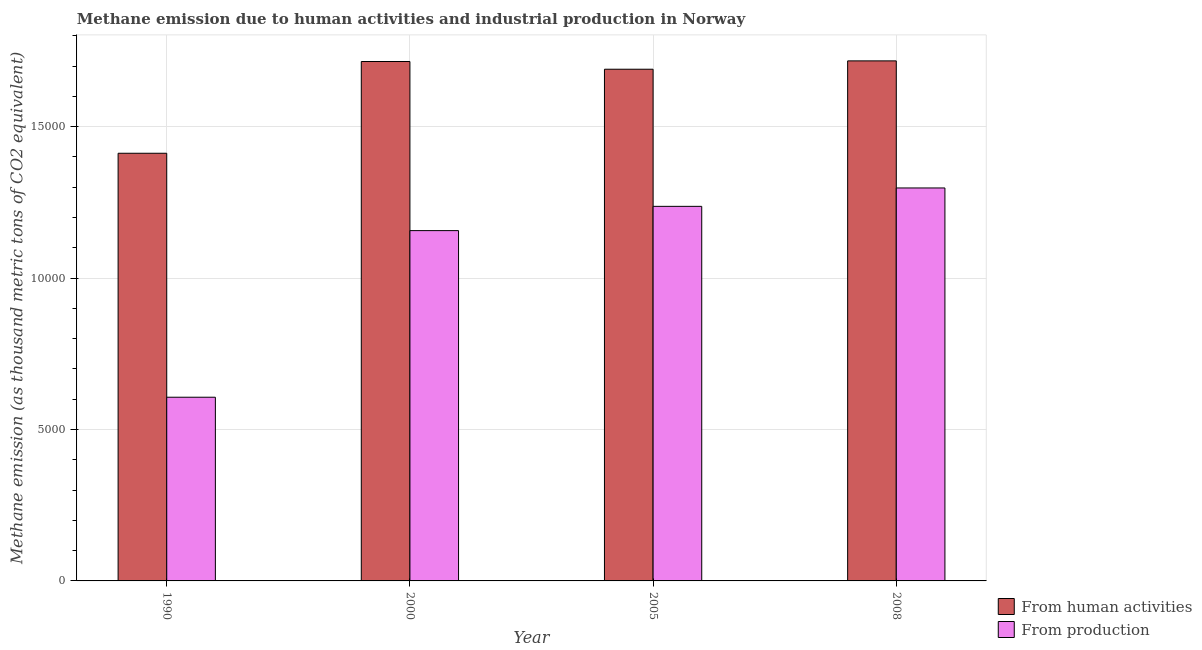Are the number of bars on each tick of the X-axis equal?
Provide a succinct answer. Yes. How many bars are there on the 3rd tick from the right?
Provide a succinct answer. 2. What is the label of the 1st group of bars from the left?
Keep it short and to the point. 1990. What is the amount of emissions from human activities in 2000?
Offer a terse response. 1.72e+04. Across all years, what is the maximum amount of emissions from human activities?
Offer a terse response. 1.72e+04. Across all years, what is the minimum amount of emissions generated from industries?
Your answer should be very brief. 6065.9. In which year was the amount of emissions generated from industries minimum?
Keep it short and to the point. 1990. What is the total amount of emissions generated from industries in the graph?
Your answer should be very brief. 4.30e+04. What is the difference between the amount of emissions generated from industries in 2000 and that in 2005?
Provide a succinct answer. -801. What is the difference between the amount of emissions generated from industries in 1990 and the amount of emissions from human activities in 2005?
Give a very brief answer. -6302.9. What is the average amount of emissions from human activities per year?
Your answer should be compact. 1.63e+04. What is the ratio of the amount of emissions from human activities in 2000 to that in 2005?
Your response must be concise. 1.02. Is the difference between the amount of emissions generated from industries in 2005 and 2008 greater than the difference between the amount of emissions from human activities in 2005 and 2008?
Offer a terse response. No. What is the difference between the highest and the second highest amount of emissions from human activities?
Offer a terse response. 21. What is the difference between the highest and the lowest amount of emissions generated from industries?
Offer a terse response. 6910.1. Is the sum of the amount of emissions generated from industries in 2005 and 2008 greater than the maximum amount of emissions from human activities across all years?
Give a very brief answer. Yes. What does the 1st bar from the left in 2005 represents?
Your response must be concise. From human activities. What does the 1st bar from the right in 2008 represents?
Your answer should be very brief. From production. How many bars are there?
Make the answer very short. 8. Are all the bars in the graph horizontal?
Make the answer very short. No. How many years are there in the graph?
Keep it short and to the point. 4. What is the difference between two consecutive major ticks on the Y-axis?
Provide a short and direct response. 5000. Are the values on the major ticks of Y-axis written in scientific E-notation?
Keep it short and to the point. No. Does the graph contain grids?
Offer a terse response. Yes. What is the title of the graph?
Your answer should be very brief. Methane emission due to human activities and industrial production in Norway. Does "Fixed telephone" appear as one of the legend labels in the graph?
Your answer should be very brief. No. What is the label or title of the Y-axis?
Ensure brevity in your answer.  Methane emission (as thousand metric tons of CO2 equivalent). What is the Methane emission (as thousand metric tons of CO2 equivalent) of From human activities in 1990?
Your answer should be very brief. 1.41e+04. What is the Methane emission (as thousand metric tons of CO2 equivalent) in From production in 1990?
Your response must be concise. 6065.9. What is the Methane emission (as thousand metric tons of CO2 equivalent) of From human activities in 2000?
Offer a terse response. 1.72e+04. What is the Methane emission (as thousand metric tons of CO2 equivalent) in From production in 2000?
Provide a short and direct response. 1.16e+04. What is the Methane emission (as thousand metric tons of CO2 equivalent) of From human activities in 2005?
Keep it short and to the point. 1.69e+04. What is the Methane emission (as thousand metric tons of CO2 equivalent) of From production in 2005?
Give a very brief answer. 1.24e+04. What is the Methane emission (as thousand metric tons of CO2 equivalent) of From human activities in 2008?
Ensure brevity in your answer.  1.72e+04. What is the Methane emission (as thousand metric tons of CO2 equivalent) of From production in 2008?
Make the answer very short. 1.30e+04. Across all years, what is the maximum Methane emission (as thousand metric tons of CO2 equivalent) of From human activities?
Ensure brevity in your answer.  1.72e+04. Across all years, what is the maximum Methane emission (as thousand metric tons of CO2 equivalent) of From production?
Your answer should be compact. 1.30e+04. Across all years, what is the minimum Methane emission (as thousand metric tons of CO2 equivalent) in From human activities?
Offer a very short reply. 1.41e+04. Across all years, what is the minimum Methane emission (as thousand metric tons of CO2 equivalent) of From production?
Offer a very short reply. 6065.9. What is the total Methane emission (as thousand metric tons of CO2 equivalent) of From human activities in the graph?
Give a very brief answer. 6.53e+04. What is the total Methane emission (as thousand metric tons of CO2 equivalent) in From production in the graph?
Your answer should be compact. 4.30e+04. What is the difference between the Methane emission (as thousand metric tons of CO2 equivalent) in From human activities in 1990 and that in 2000?
Offer a terse response. -3029.8. What is the difference between the Methane emission (as thousand metric tons of CO2 equivalent) in From production in 1990 and that in 2000?
Give a very brief answer. -5501.9. What is the difference between the Methane emission (as thousand metric tons of CO2 equivalent) of From human activities in 1990 and that in 2005?
Your answer should be very brief. -2775. What is the difference between the Methane emission (as thousand metric tons of CO2 equivalent) in From production in 1990 and that in 2005?
Offer a terse response. -6302.9. What is the difference between the Methane emission (as thousand metric tons of CO2 equivalent) of From human activities in 1990 and that in 2008?
Give a very brief answer. -3050.8. What is the difference between the Methane emission (as thousand metric tons of CO2 equivalent) in From production in 1990 and that in 2008?
Your response must be concise. -6910.1. What is the difference between the Methane emission (as thousand metric tons of CO2 equivalent) in From human activities in 2000 and that in 2005?
Keep it short and to the point. 254.8. What is the difference between the Methane emission (as thousand metric tons of CO2 equivalent) in From production in 2000 and that in 2005?
Your answer should be compact. -801. What is the difference between the Methane emission (as thousand metric tons of CO2 equivalent) of From human activities in 2000 and that in 2008?
Make the answer very short. -21. What is the difference between the Methane emission (as thousand metric tons of CO2 equivalent) of From production in 2000 and that in 2008?
Make the answer very short. -1408.2. What is the difference between the Methane emission (as thousand metric tons of CO2 equivalent) in From human activities in 2005 and that in 2008?
Your answer should be very brief. -275.8. What is the difference between the Methane emission (as thousand metric tons of CO2 equivalent) of From production in 2005 and that in 2008?
Give a very brief answer. -607.2. What is the difference between the Methane emission (as thousand metric tons of CO2 equivalent) of From human activities in 1990 and the Methane emission (as thousand metric tons of CO2 equivalent) of From production in 2000?
Your answer should be compact. 2554.1. What is the difference between the Methane emission (as thousand metric tons of CO2 equivalent) in From human activities in 1990 and the Methane emission (as thousand metric tons of CO2 equivalent) in From production in 2005?
Your answer should be very brief. 1753.1. What is the difference between the Methane emission (as thousand metric tons of CO2 equivalent) of From human activities in 1990 and the Methane emission (as thousand metric tons of CO2 equivalent) of From production in 2008?
Offer a very short reply. 1145.9. What is the difference between the Methane emission (as thousand metric tons of CO2 equivalent) in From human activities in 2000 and the Methane emission (as thousand metric tons of CO2 equivalent) in From production in 2005?
Offer a terse response. 4782.9. What is the difference between the Methane emission (as thousand metric tons of CO2 equivalent) of From human activities in 2000 and the Methane emission (as thousand metric tons of CO2 equivalent) of From production in 2008?
Make the answer very short. 4175.7. What is the difference between the Methane emission (as thousand metric tons of CO2 equivalent) in From human activities in 2005 and the Methane emission (as thousand metric tons of CO2 equivalent) in From production in 2008?
Your response must be concise. 3920.9. What is the average Methane emission (as thousand metric tons of CO2 equivalent) in From human activities per year?
Your answer should be compact. 1.63e+04. What is the average Methane emission (as thousand metric tons of CO2 equivalent) in From production per year?
Provide a short and direct response. 1.07e+04. In the year 1990, what is the difference between the Methane emission (as thousand metric tons of CO2 equivalent) of From human activities and Methane emission (as thousand metric tons of CO2 equivalent) of From production?
Offer a terse response. 8056. In the year 2000, what is the difference between the Methane emission (as thousand metric tons of CO2 equivalent) of From human activities and Methane emission (as thousand metric tons of CO2 equivalent) of From production?
Ensure brevity in your answer.  5583.9. In the year 2005, what is the difference between the Methane emission (as thousand metric tons of CO2 equivalent) of From human activities and Methane emission (as thousand metric tons of CO2 equivalent) of From production?
Your response must be concise. 4528.1. In the year 2008, what is the difference between the Methane emission (as thousand metric tons of CO2 equivalent) of From human activities and Methane emission (as thousand metric tons of CO2 equivalent) of From production?
Provide a succinct answer. 4196.7. What is the ratio of the Methane emission (as thousand metric tons of CO2 equivalent) in From human activities in 1990 to that in 2000?
Your answer should be very brief. 0.82. What is the ratio of the Methane emission (as thousand metric tons of CO2 equivalent) in From production in 1990 to that in 2000?
Your response must be concise. 0.52. What is the ratio of the Methane emission (as thousand metric tons of CO2 equivalent) in From human activities in 1990 to that in 2005?
Offer a terse response. 0.84. What is the ratio of the Methane emission (as thousand metric tons of CO2 equivalent) in From production in 1990 to that in 2005?
Keep it short and to the point. 0.49. What is the ratio of the Methane emission (as thousand metric tons of CO2 equivalent) in From human activities in 1990 to that in 2008?
Offer a terse response. 0.82. What is the ratio of the Methane emission (as thousand metric tons of CO2 equivalent) in From production in 1990 to that in 2008?
Provide a succinct answer. 0.47. What is the ratio of the Methane emission (as thousand metric tons of CO2 equivalent) of From human activities in 2000 to that in 2005?
Your answer should be very brief. 1.02. What is the ratio of the Methane emission (as thousand metric tons of CO2 equivalent) in From production in 2000 to that in 2005?
Keep it short and to the point. 0.94. What is the ratio of the Methane emission (as thousand metric tons of CO2 equivalent) of From production in 2000 to that in 2008?
Ensure brevity in your answer.  0.89. What is the ratio of the Methane emission (as thousand metric tons of CO2 equivalent) of From human activities in 2005 to that in 2008?
Provide a short and direct response. 0.98. What is the ratio of the Methane emission (as thousand metric tons of CO2 equivalent) in From production in 2005 to that in 2008?
Make the answer very short. 0.95. What is the difference between the highest and the second highest Methane emission (as thousand metric tons of CO2 equivalent) of From human activities?
Make the answer very short. 21. What is the difference between the highest and the second highest Methane emission (as thousand metric tons of CO2 equivalent) of From production?
Your answer should be compact. 607.2. What is the difference between the highest and the lowest Methane emission (as thousand metric tons of CO2 equivalent) in From human activities?
Your answer should be very brief. 3050.8. What is the difference between the highest and the lowest Methane emission (as thousand metric tons of CO2 equivalent) of From production?
Ensure brevity in your answer.  6910.1. 